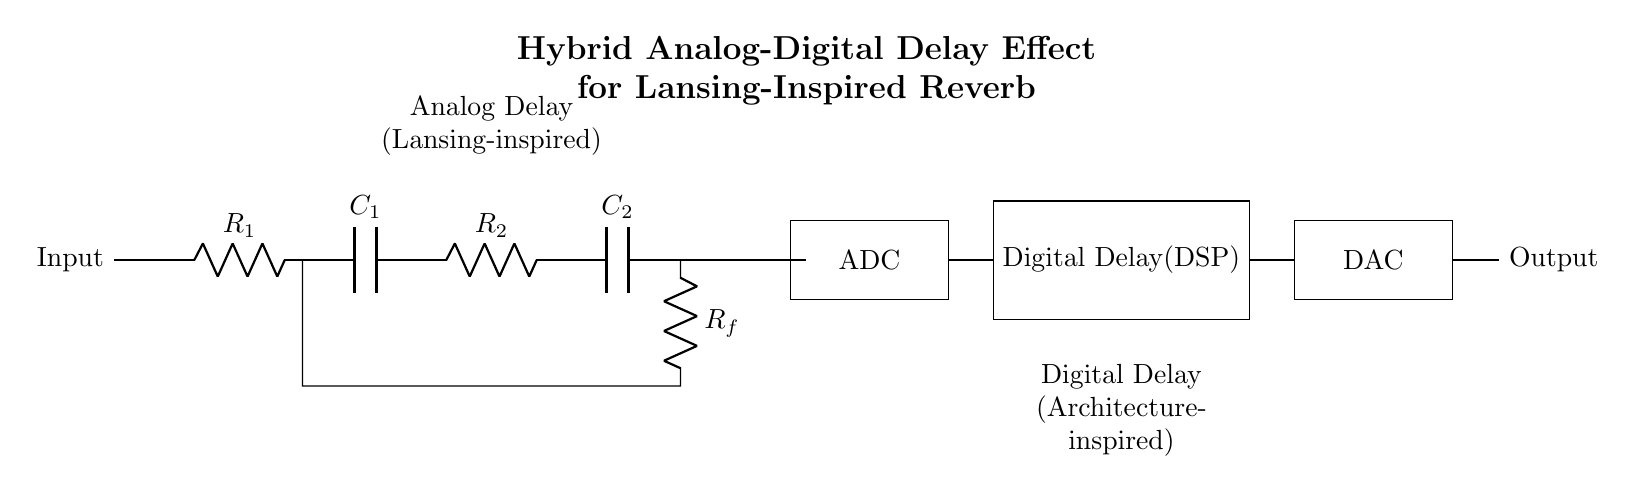What is the component that receives the input signal? The component that receives the input signal is the resistor labeled as R_1, which is connected directly to the input.
Answer: R_1 What type of circuit is depicted in this diagram? The circuit type presented is a hybrid analog-digital delay effect circuit, integrating both analog and digital processing.
Answer: Hybrid analog-digital delay What components are used for the analog delay section? The components used in the analog delay section are two resistors (R_1 and R_2) and two capacitors (C_1 and C_2) connected in series.
Answer: R_1, R_2, C_1, C_2 How many converters are shown in this circuit? There are two types of converters shown: one A/D converter and one D/A converter, indicating a conversion from analog to digital and vice versa.
Answer: Two What does DSP stand for in this circuit? DSP stands for Digital Signal Processing, which refers to the section of the circuit that handles the digital delay.
Answer: Digital Signal Processing Where does the feedback loop connect in this circuit diagram? The feedback loop connects from the output of R_f back to the input of the first component in the analog delay section, creating a feedback path for the delayed signal.
Answer: To R_1 What is the purpose of the ADC in this circuit? The purpose of the A/D converter (ADC) is to convert the analog signal coming from the analog delay section into a digital signal for processing in the DSP.
Answer: Convert analog to digital 